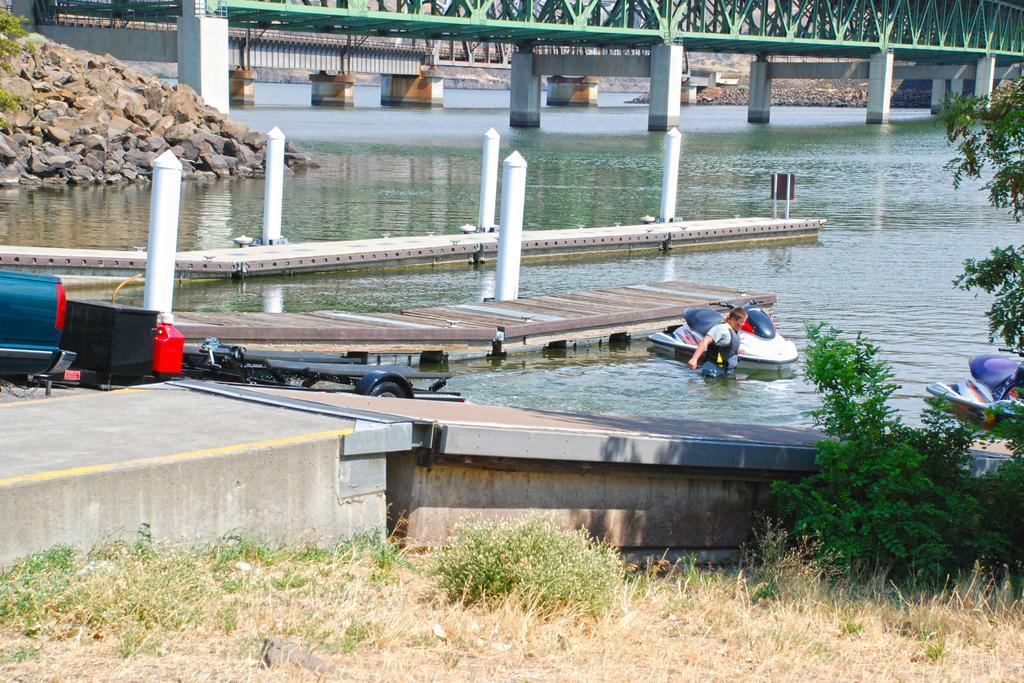In one or two sentences, can you explain what this image depicts? There is one person and some boats are in the Sea as we can see in the middle of this image. There are some stones on the left side of this image. The bridge is at the top of this image and there are some plants and trees at the bottom of this image. 